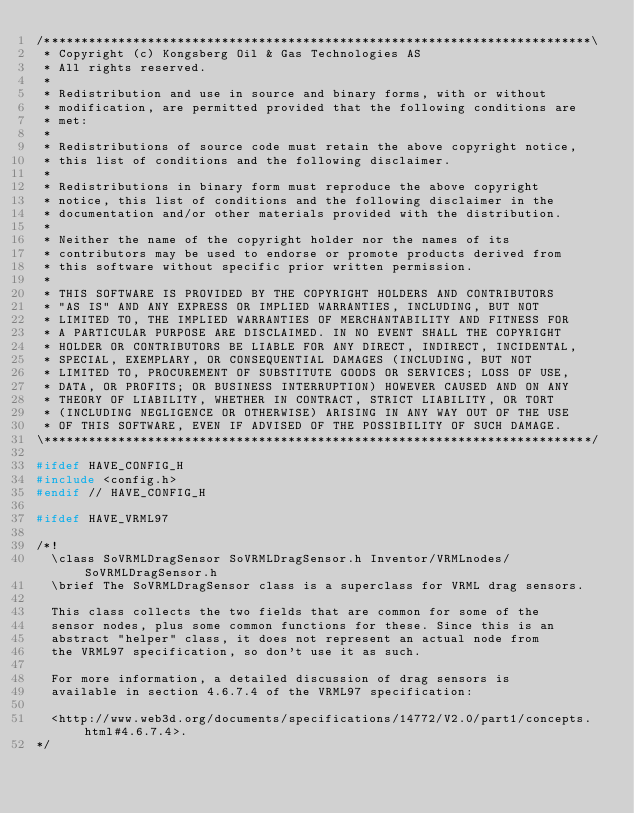Convert code to text. <code><loc_0><loc_0><loc_500><loc_500><_C++_>/**************************************************************************\
 * Copyright (c) Kongsberg Oil & Gas Technologies AS
 * All rights reserved.
 * 
 * Redistribution and use in source and binary forms, with or without
 * modification, are permitted provided that the following conditions are
 * met:
 * 
 * Redistributions of source code must retain the above copyright notice,
 * this list of conditions and the following disclaimer.
 * 
 * Redistributions in binary form must reproduce the above copyright
 * notice, this list of conditions and the following disclaimer in the
 * documentation and/or other materials provided with the distribution.
 * 
 * Neither the name of the copyright holder nor the names of its
 * contributors may be used to endorse or promote products derived from
 * this software without specific prior written permission.
 * 
 * THIS SOFTWARE IS PROVIDED BY THE COPYRIGHT HOLDERS AND CONTRIBUTORS
 * "AS IS" AND ANY EXPRESS OR IMPLIED WARRANTIES, INCLUDING, BUT NOT
 * LIMITED TO, THE IMPLIED WARRANTIES OF MERCHANTABILITY AND FITNESS FOR
 * A PARTICULAR PURPOSE ARE DISCLAIMED. IN NO EVENT SHALL THE COPYRIGHT
 * HOLDER OR CONTRIBUTORS BE LIABLE FOR ANY DIRECT, INDIRECT, INCIDENTAL,
 * SPECIAL, EXEMPLARY, OR CONSEQUENTIAL DAMAGES (INCLUDING, BUT NOT
 * LIMITED TO, PROCUREMENT OF SUBSTITUTE GOODS OR SERVICES; LOSS OF USE,
 * DATA, OR PROFITS; OR BUSINESS INTERRUPTION) HOWEVER CAUSED AND ON ANY
 * THEORY OF LIABILITY, WHETHER IN CONTRACT, STRICT LIABILITY, OR TORT
 * (INCLUDING NEGLIGENCE OR OTHERWISE) ARISING IN ANY WAY OUT OF THE USE
 * OF THIS SOFTWARE, EVEN IF ADVISED OF THE POSSIBILITY OF SUCH DAMAGE.
\**************************************************************************/

#ifdef HAVE_CONFIG_H
#include <config.h>
#endif // HAVE_CONFIG_H

#ifdef HAVE_VRML97

/*!
  \class SoVRMLDragSensor SoVRMLDragSensor.h Inventor/VRMLnodes/SoVRMLDragSensor.h
  \brief The SoVRMLDragSensor class is a superclass for VRML drag sensors.

  This class collects the two fields that are common for some of the
  sensor nodes, plus some common functions for these. Since this is an
  abstract "helper" class, it does not represent an actual node from
  the VRML97 specification, so don't use it as such.

  For more information, a detailed discussion of drag sensors is
  available in section 4.6.7.4 of the VRML97 specification:

  <http://www.web3d.org/documents/specifications/14772/V2.0/part1/concepts.html#4.6.7.4>.
*/
</code> 